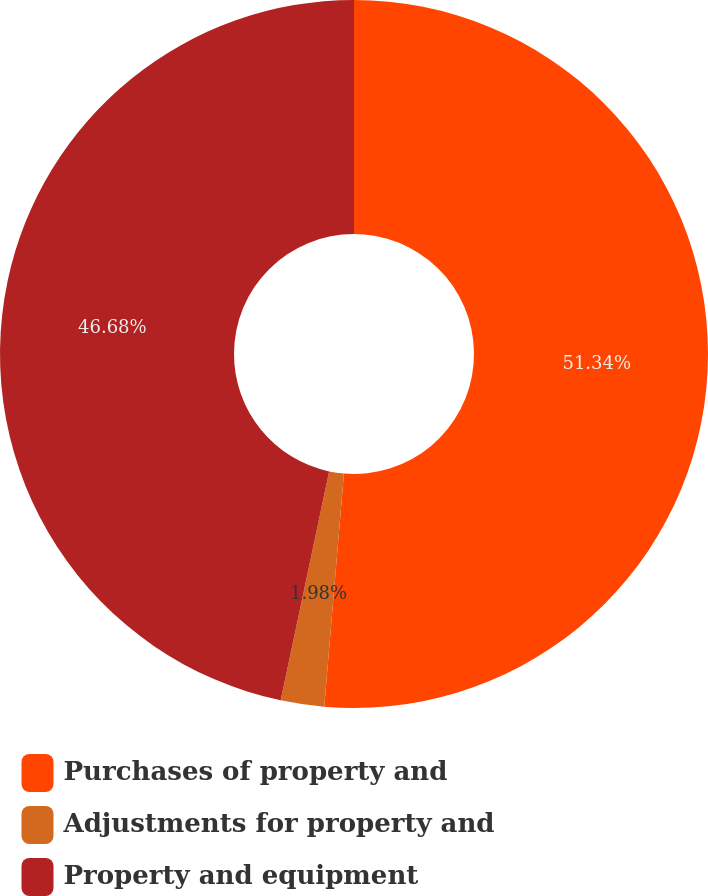<chart> <loc_0><loc_0><loc_500><loc_500><pie_chart><fcel>Purchases of property and<fcel>Adjustments for property and<fcel>Property and equipment<nl><fcel>51.34%<fcel>1.98%<fcel>46.68%<nl></chart> 